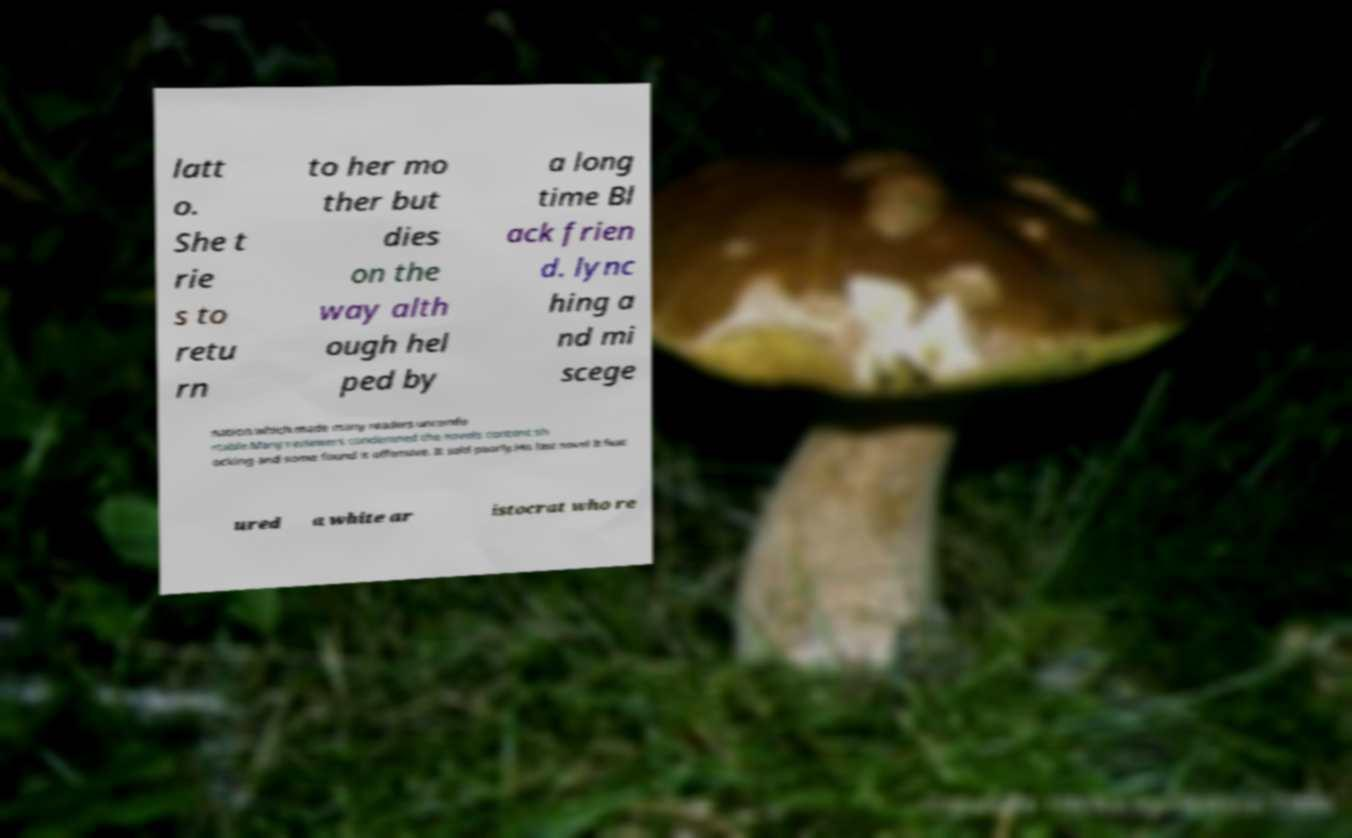What messages or text are displayed in this image? I need them in a readable, typed format. latt o. She t rie s to retu rn to her mo ther but dies on the way alth ough hel ped by a long time Bl ack frien d. lync hing a nd mi scege nation which made many readers uncomfo rtable.Many reviewers condemned the novels content sh ocking and some found it offensive. It sold poorly.His last novel It feat ured a white ar istocrat who re 